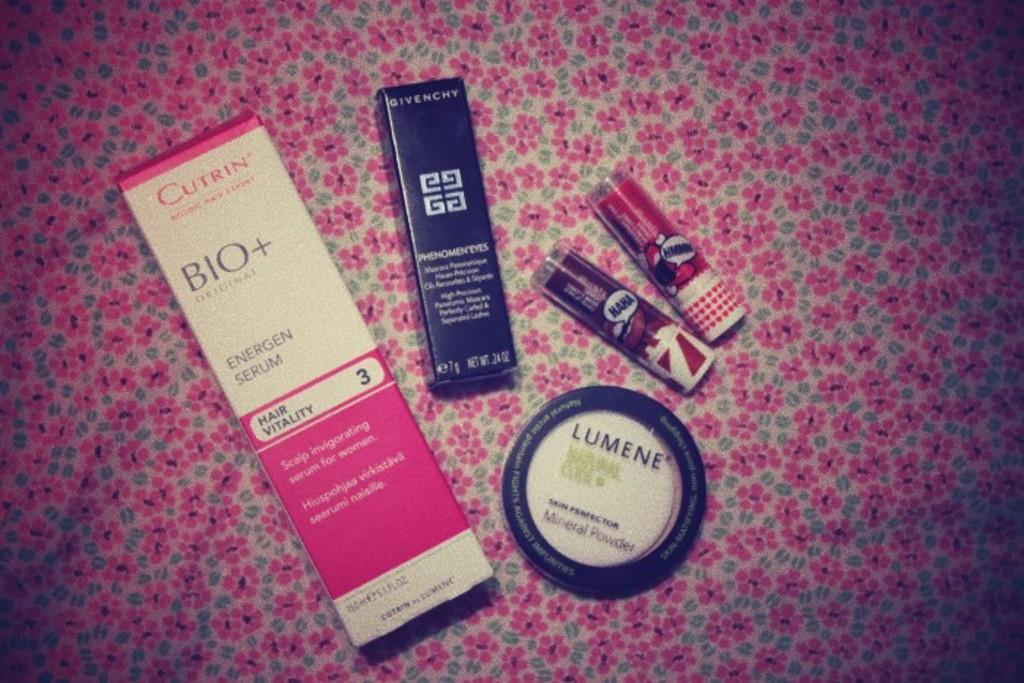<image>
Present a compact description of the photo's key features. Various health and beauty items, which includes Lumene mineral powder. 